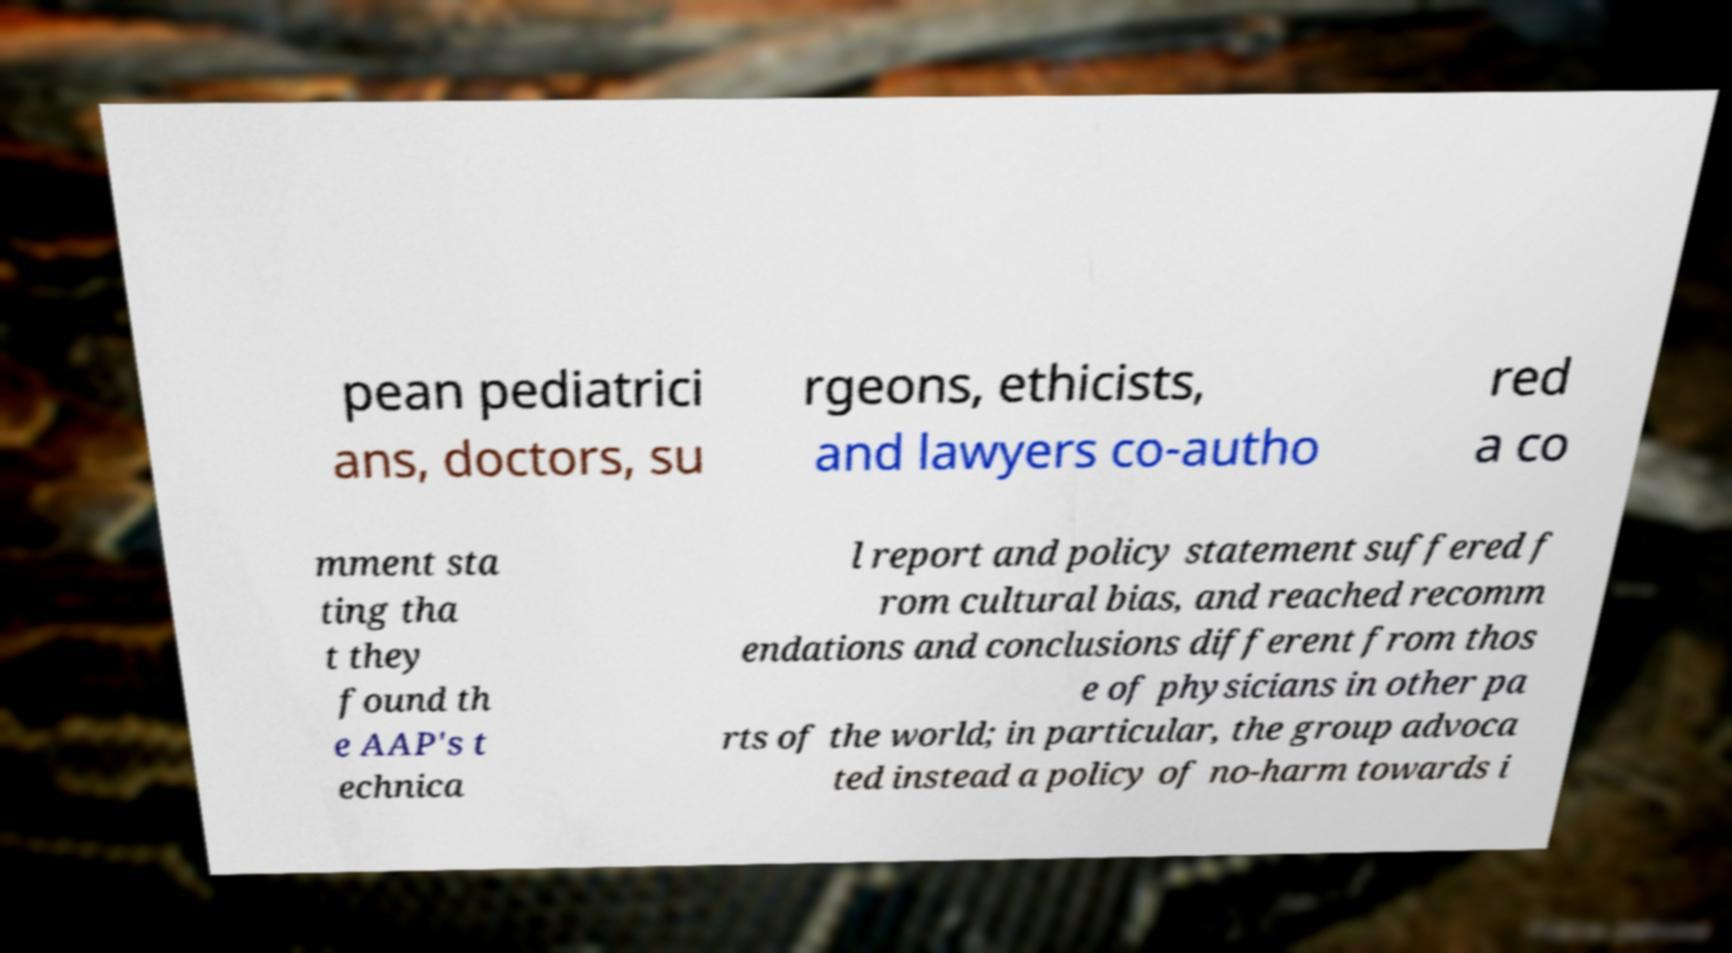Please identify and transcribe the text found in this image. pean pediatrici ans, doctors, su rgeons, ethicists, and lawyers co-autho red a co mment sta ting tha t they found th e AAP's t echnica l report and policy statement suffered f rom cultural bias, and reached recomm endations and conclusions different from thos e of physicians in other pa rts of the world; in particular, the group advoca ted instead a policy of no-harm towards i 